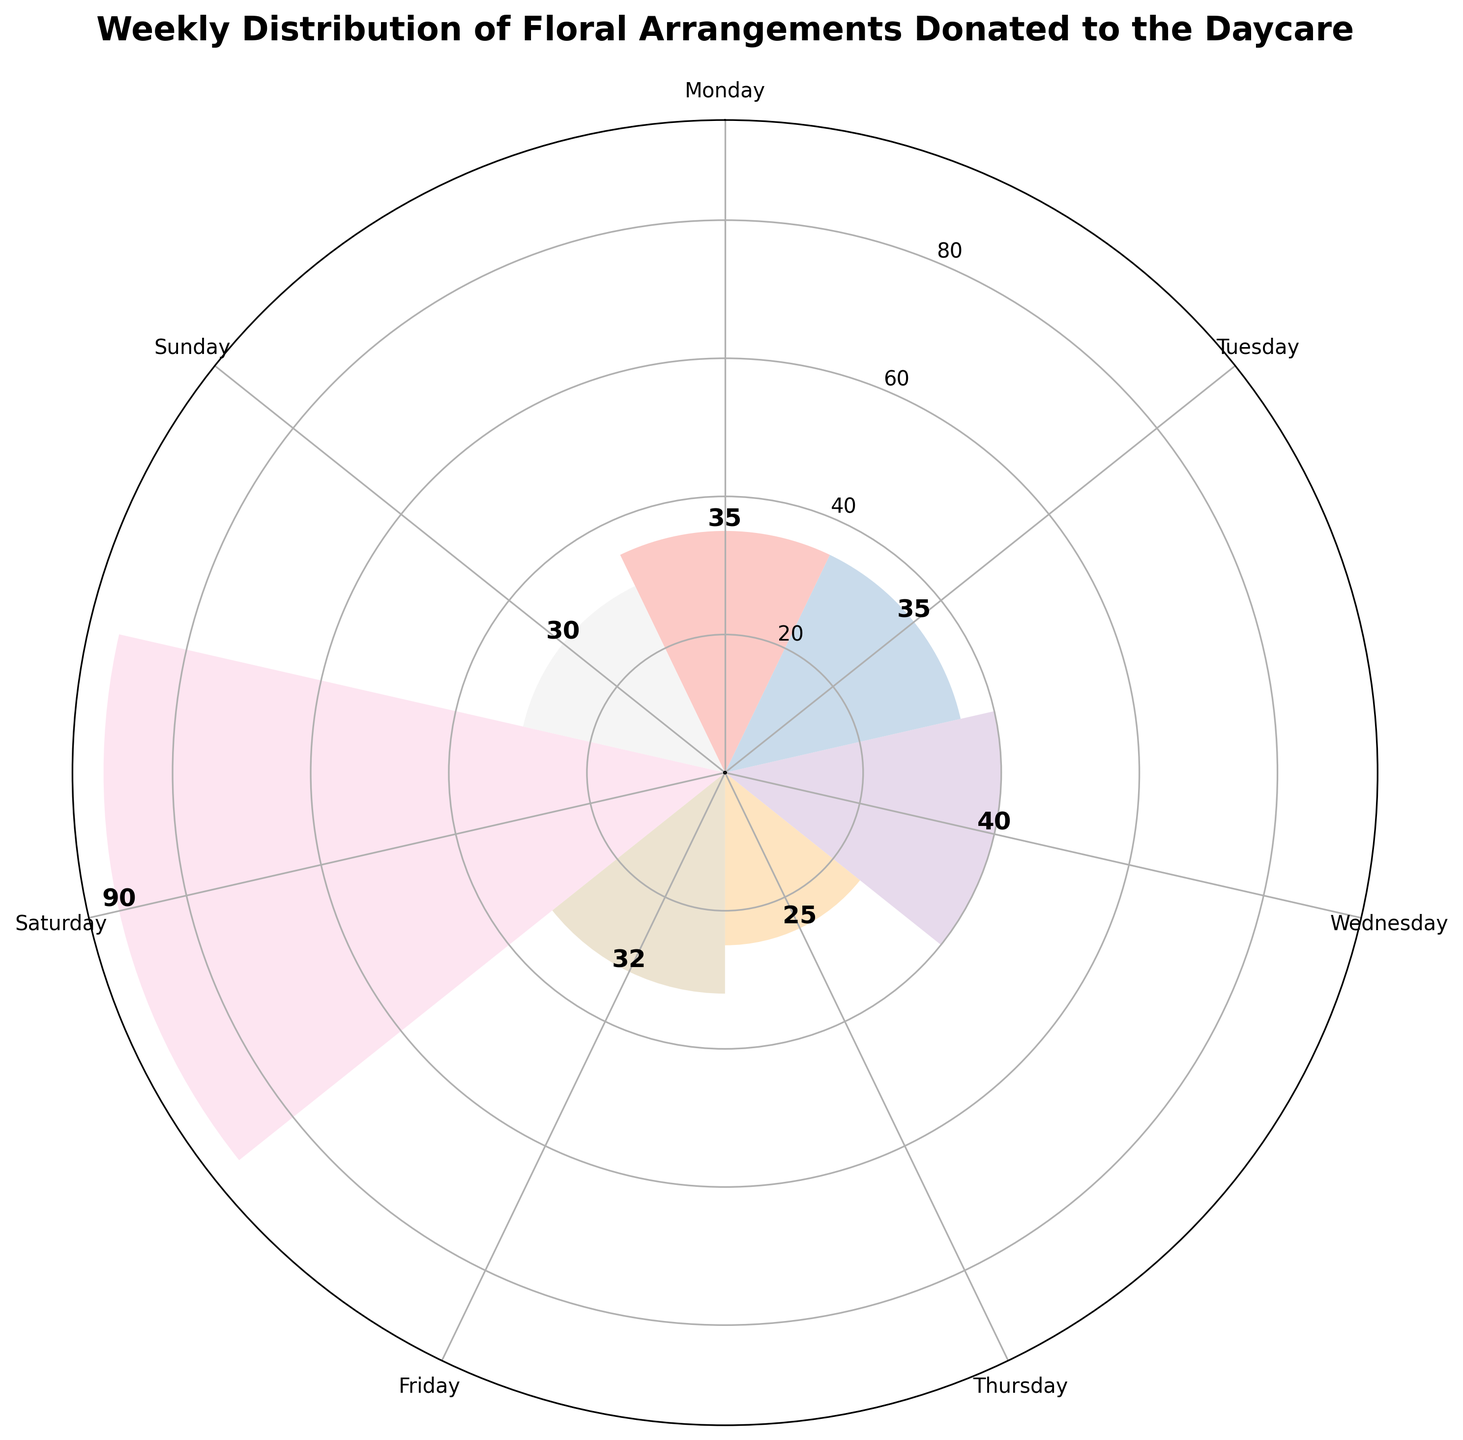How many floral arrangements were donated on Monday? By looking at the figure, find the segment labeled 'Monday' and read the numerical value inside or near the corresponding bar.
Answer: 35 Which day had the highest number of floral arrangements donated? Locate the largest bar in the rose chart and check the day label associated with it. This bar corresponds to Saturday.
Answer: Saturday Compare the donations of Roses on Monday and Tuesday. Which day had more? Identify the quantities for Roses on Monday and Tuesday (20 and 25, respectively) from the figure and compare them. Tuesday has more Roses donated.
Answer: Tuesday What is the total number of Peonies donated during the week? Identify the days where Peonies were donated (Friday and Saturday), find the numerical values (12 and 25, respectively), and sum them up. 12 + 25 = 37.
Answer: 37 What is the least donated arrangement type on Thursday? Locate the sections of Thursday in the rose chart and compare the quantities for Orchids, Sunflowers, and Roses. Orchids have the smallest quantity (5).
Answer: Orchids What is the average number of arrangements donated per day? Sum the quantities for all days: 35 + 35 + 40 + 25 + 32 + 90 + 30 = 287. Divide this sum by the number of days (7). 287 / 7 = 41.
Answer: 41 Which day had donations from the highest variety of flowers? Look at each segment of the rose chart and check the number of different floral types per day. Thursday has three types (Orchids, Sunflowers, Roses), while others have fewer or the same variety but not exceeding three.
Answer: Thursday Which day showed Florals with the minimum amount donated and what was the type? Identify the bar with the smallest value in the rose chart, which corresponds to the Orchids donated on Thursday. The minimum donated type is 5 arrangements of Orchids.
Answer: Orchids, Thursday 